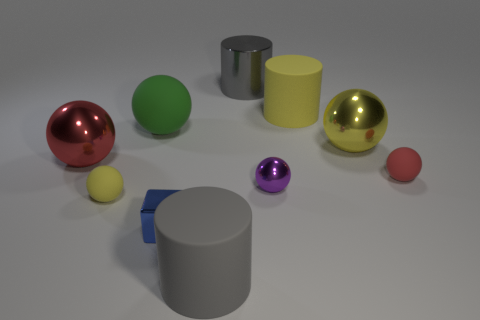What materials do the objects in the image appear to be made of? The objects in the image seem to vary in material; the spheres have a reflective quality suggestive of polished metal or plastic, and the cylinders look to have a matte finish, possibly resembling ceramic or plastic. 